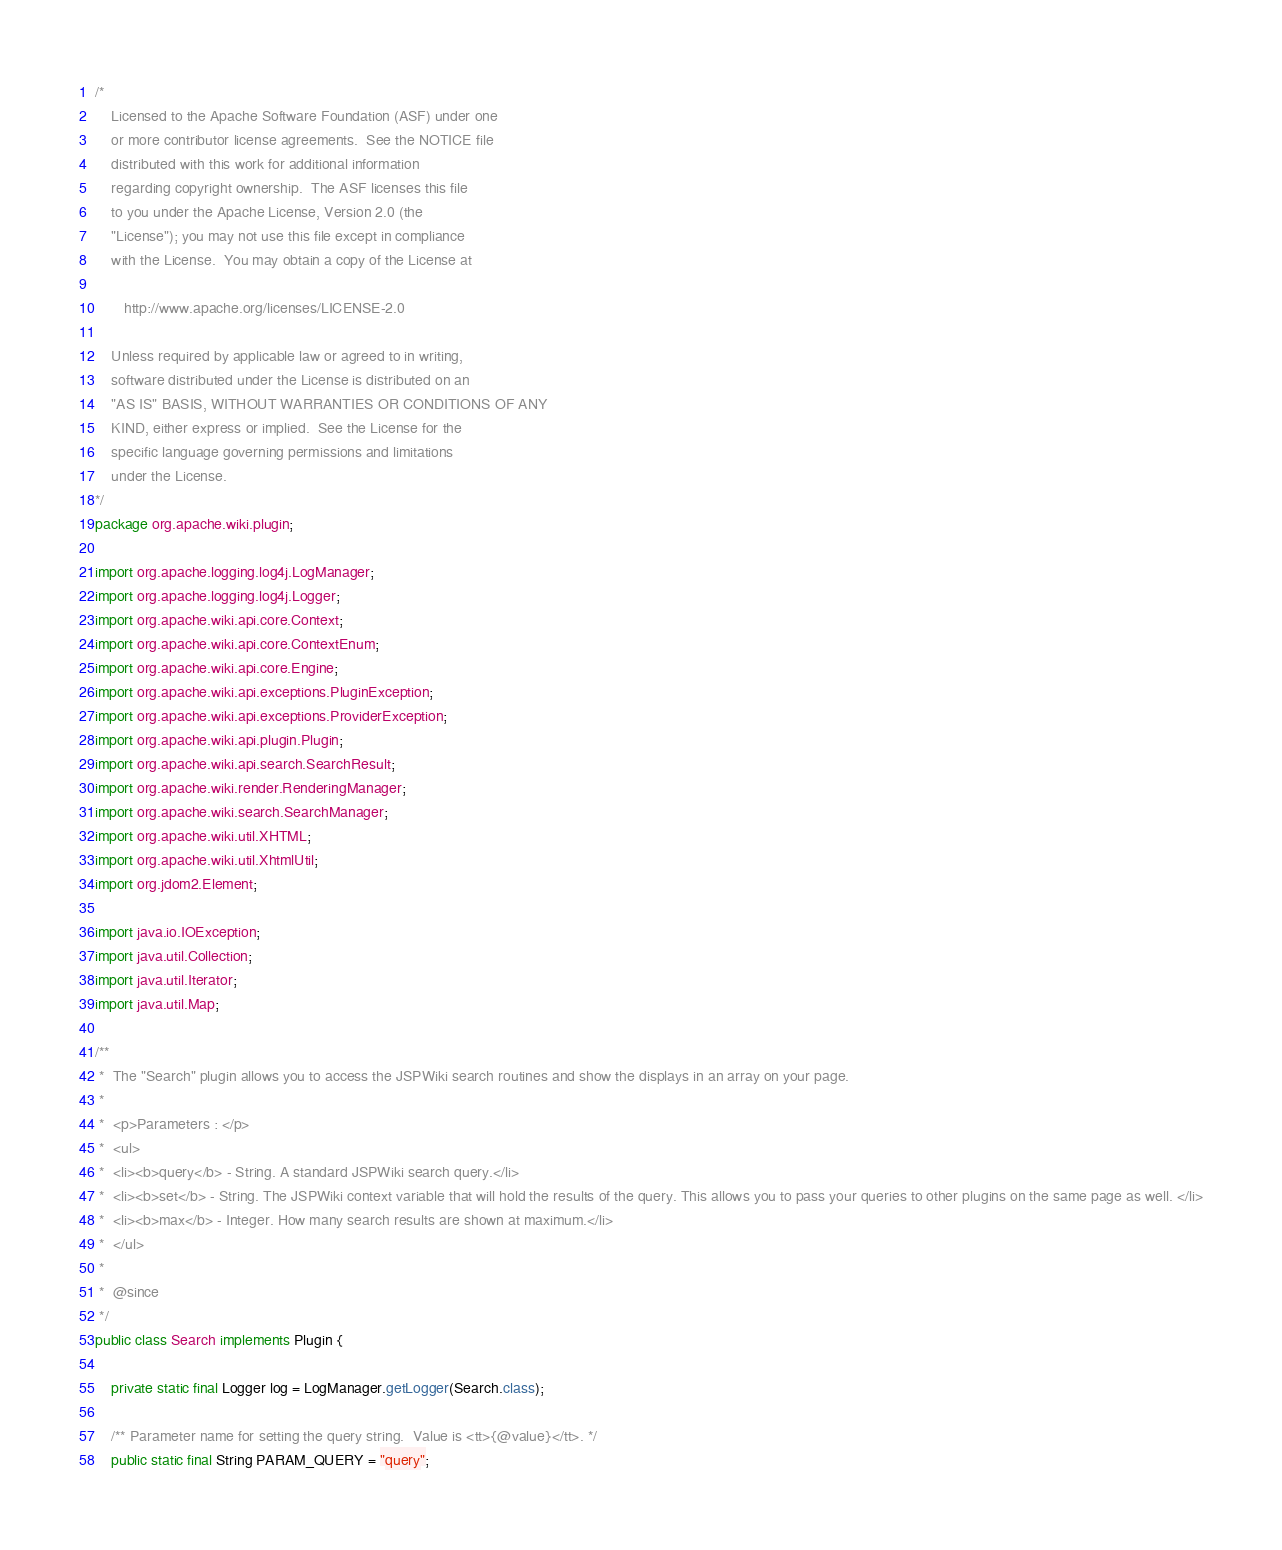Convert code to text. <code><loc_0><loc_0><loc_500><loc_500><_Java_>/*
    Licensed to the Apache Software Foundation (ASF) under one
    or more contributor license agreements.  See the NOTICE file
    distributed with this work for additional information
    regarding copyright ownership.  The ASF licenses this file
    to you under the Apache License, Version 2.0 (the
    "License"); you may not use this file except in compliance
    with the License.  You may obtain a copy of the License at

       http://www.apache.org/licenses/LICENSE-2.0

    Unless required by applicable law or agreed to in writing,
    software distributed under the License is distributed on an
    "AS IS" BASIS, WITHOUT WARRANTIES OR CONDITIONS OF ANY
    KIND, either express or implied.  See the License for the
    specific language governing permissions and limitations
    under the License.
*/
package org.apache.wiki.plugin;

import org.apache.logging.log4j.LogManager;
import org.apache.logging.log4j.Logger;
import org.apache.wiki.api.core.Context;
import org.apache.wiki.api.core.ContextEnum;
import org.apache.wiki.api.core.Engine;
import org.apache.wiki.api.exceptions.PluginException;
import org.apache.wiki.api.exceptions.ProviderException;
import org.apache.wiki.api.plugin.Plugin;
import org.apache.wiki.api.search.SearchResult;
import org.apache.wiki.render.RenderingManager;
import org.apache.wiki.search.SearchManager;
import org.apache.wiki.util.XHTML;
import org.apache.wiki.util.XhtmlUtil;
import org.jdom2.Element;

import java.io.IOException;
import java.util.Collection;
import java.util.Iterator;
import java.util.Map;

/**
 *  The "Search" plugin allows you to access the JSPWiki search routines and show the displays in an array on your page.
 *
 *  <p>Parameters : </p>
 *  <ul>
 *  <li><b>query</b> - String. A standard JSPWiki search query.</li>
 *  <li><b>set</b> - String. The JSPWiki context variable that will hold the results of the query. This allows you to pass your queries to other plugins on the same page as well. </li>
 *  <li><b>max</b> - Integer. How many search results are shown at maximum.</li>
 *  </ul>
 *
 *  @since
 */
public class Search implements Plugin {

    private static final Logger log = LogManager.getLogger(Search.class);

    /** Parameter name for setting the query string.  Value is <tt>{@value}</tt>. */
    public static final String PARAM_QUERY = "query";
</code> 